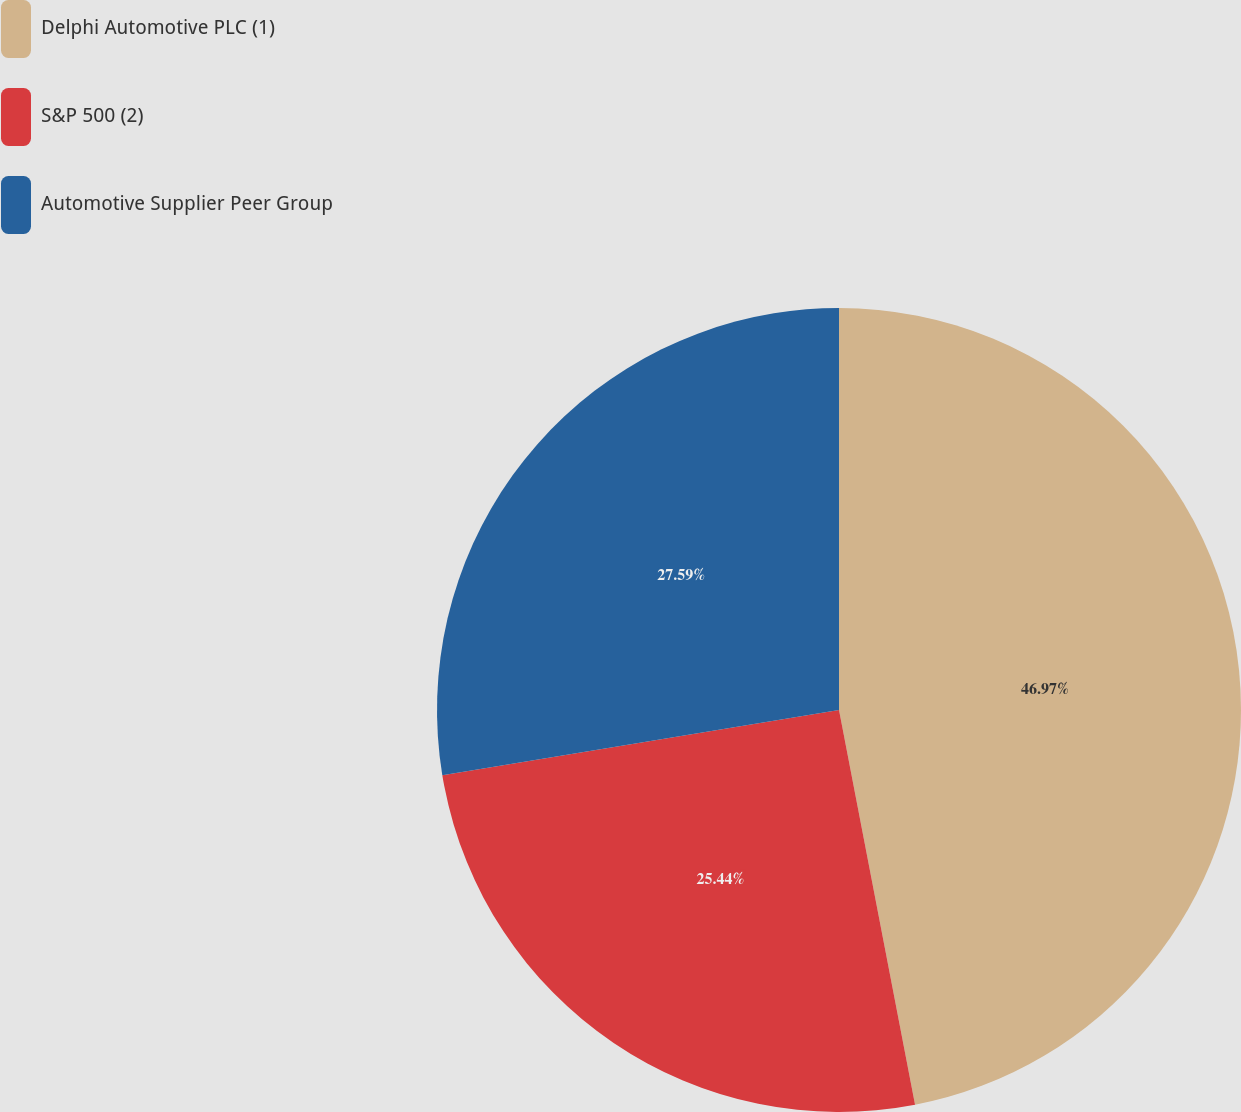Convert chart to OTSL. <chart><loc_0><loc_0><loc_500><loc_500><pie_chart><fcel>Delphi Automotive PLC (1)<fcel>S&P 500 (2)<fcel>Automotive Supplier Peer Group<nl><fcel>46.97%<fcel>25.44%<fcel>27.59%<nl></chart> 